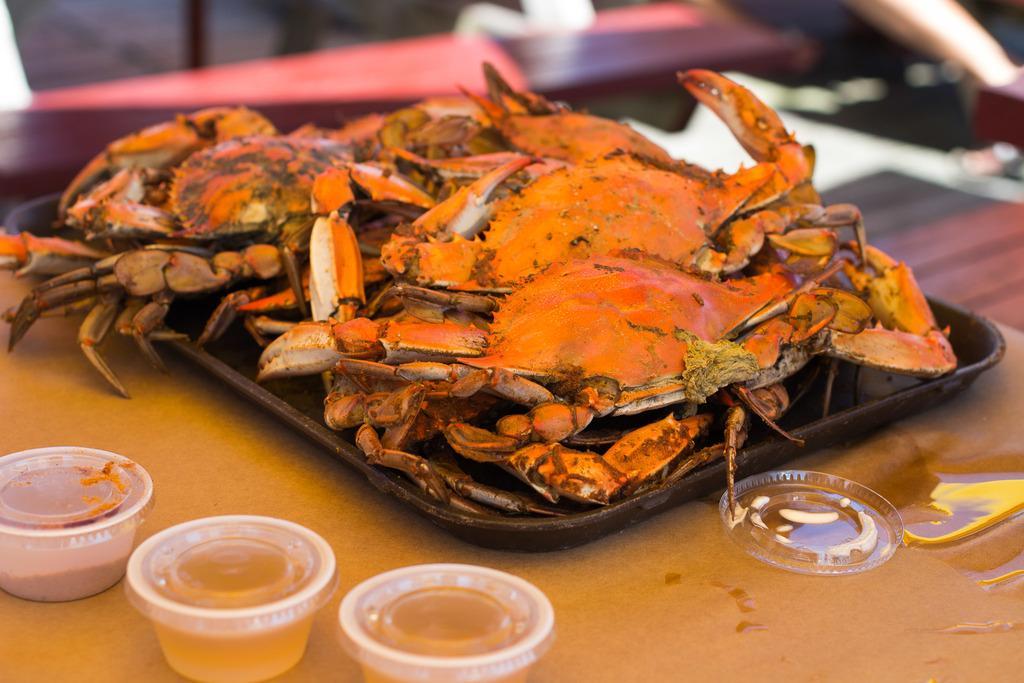Describe this image in one or two sentences. At the bottom of the image there is a table and we can see crabs, tray, bowls and sauce placed on the table. 